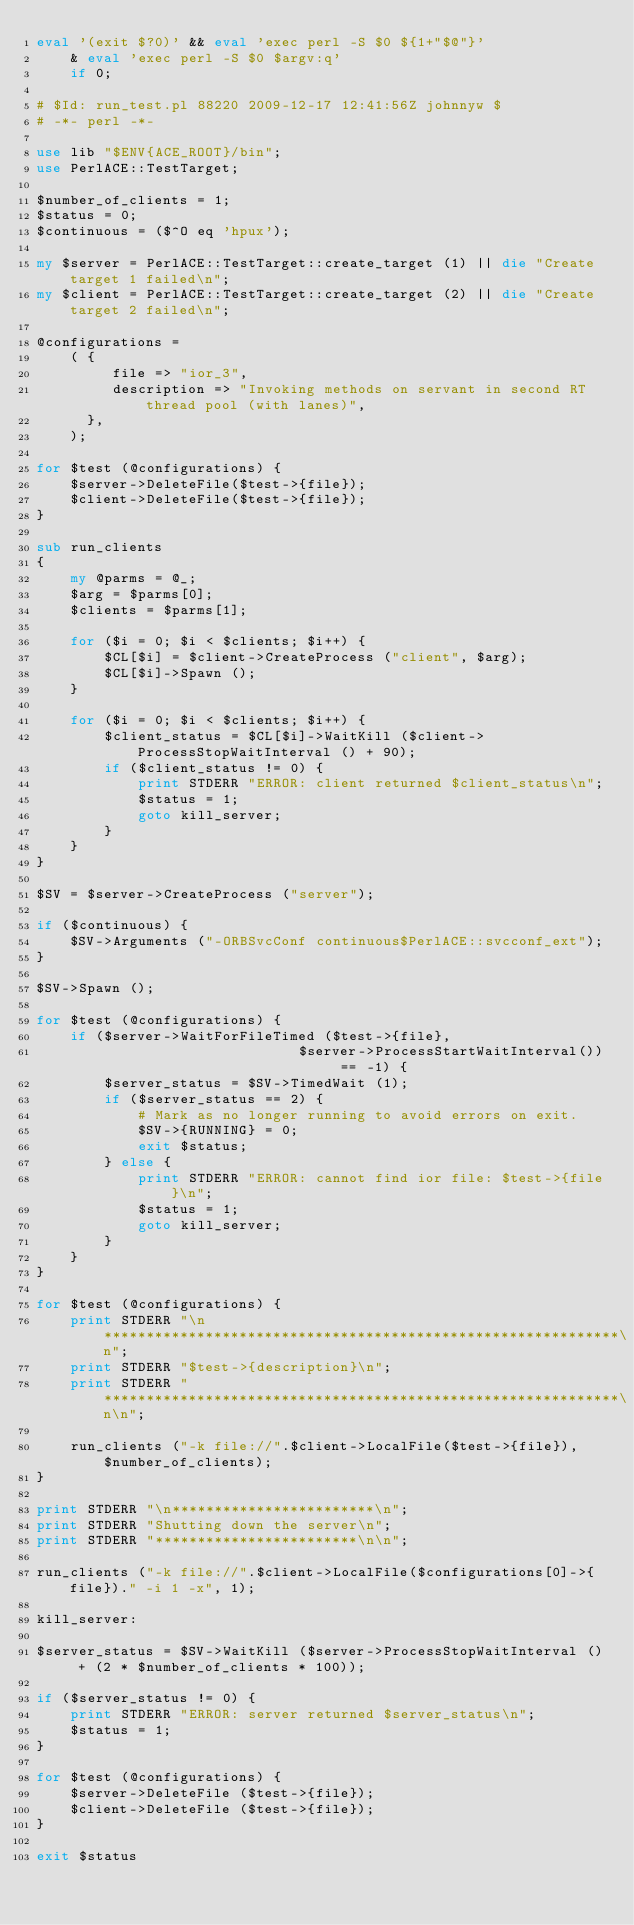<code> <loc_0><loc_0><loc_500><loc_500><_Perl_>eval '(exit $?0)' && eval 'exec perl -S $0 ${1+"$@"}'
    & eval 'exec perl -S $0 $argv:q'
    if 0;

# $Id: run_test.pl 88220 2009-12-17 12:41:56Z johnnyw $
# -*- perl -*-

use lib "$ENV{ACE_ROOT}/bin";
use PerlACE::TestTarget;

$number_of_clients = 1;
$status = 0;
$continuous = ($^O eq 'hpux');

my $server = PerlACE::TestTarget::create_target (1) || die "Create target 1 failed\n";
my $client = PerlACE::TestTarget::create_target (2) || die "Create target 2 failed\n";

@configurations =
    ( {
         file => "ior_3",
         description => "Invoking methods on servant in second RT thread pool (with lanes)",
      },
    );

for $test (@configurations) {
    $server->DeleteFile($test->{file});
    $client->DeleteFile($test->{file});
}

sub run_clients
{
    my @parms = @_;
    $arg = $parms[0];
    $clients = $parms[1];

    for ($i = 0; $i < $clients; $i++) {
        $CL[$i] = $client->CreateProcess ("client", $arg);
        $CL[$i]->Spawn ();
    }

    for ($i = 0; $i < $clients; $i++) {
        $client_status = $CL[$i]->WaitKill ($client->ProcessStopWaitInterval () + 90);
        if ($client_status != 0) {
            print STDERR "ERROR: client returned $client_status\n";
            $status = 1;
            goto kill_server;
        }
    }
}

$SV = $server->CreateProcess ("server");

if ($continuous) {
    $SV->Arguments ("-ORBSvcConf continuous$PerlACE::svcconf_ext");
}

$SV->Spawn ();

for $test (@configurations) {
    if ($server->WaitForFileTimed ($test->{file},
                               $server->ProcessStartWaitInterval()) == -1) {
        $server_status = $SV->TimedWait (1);
        if ($server_status == 2) {
            # Mark as no longer running to avoid errors on exit.
            $SV->{RUNNING} = 0;
            exit $status;
        } else {
            print STDERR "ERROR: cannot find ior file: $test->{file}\n";
            $status = 1;
            goto kill_server;
        }
    }
}

for $test (@configurations) {
    print STDERR "\n*************************************************************\n";
    print STDERR "$test->{description}\n";
    print STDERR "*************************************************************\n\n";

    run_clients ("-k file://".$client->LocalFile($test->{file}), $number_of_clients);
}

print STDERR "\n************************\n";
print STDERR "Shutting down the server\n";
print STDERR "************************\n\n";

run_clients ("-k file://".$client->LocalFile($configurations[0]->{file})." -i 1 -x", 1);

kill_server:

$server_status = $SV->WaitKill ($server->ProcessStopWaitInterval () + (2 * $number_of_clients * 100));

if ($server_status != 0) {
    print STDERR "ERROR: server returned $server_status\n";
    $status = 1;
}

for $test (@configurations) {
    $server->DeleteFile ($test->{file});
    $client->DeleteFile ($test->{file});
}

exit $status

</code> 